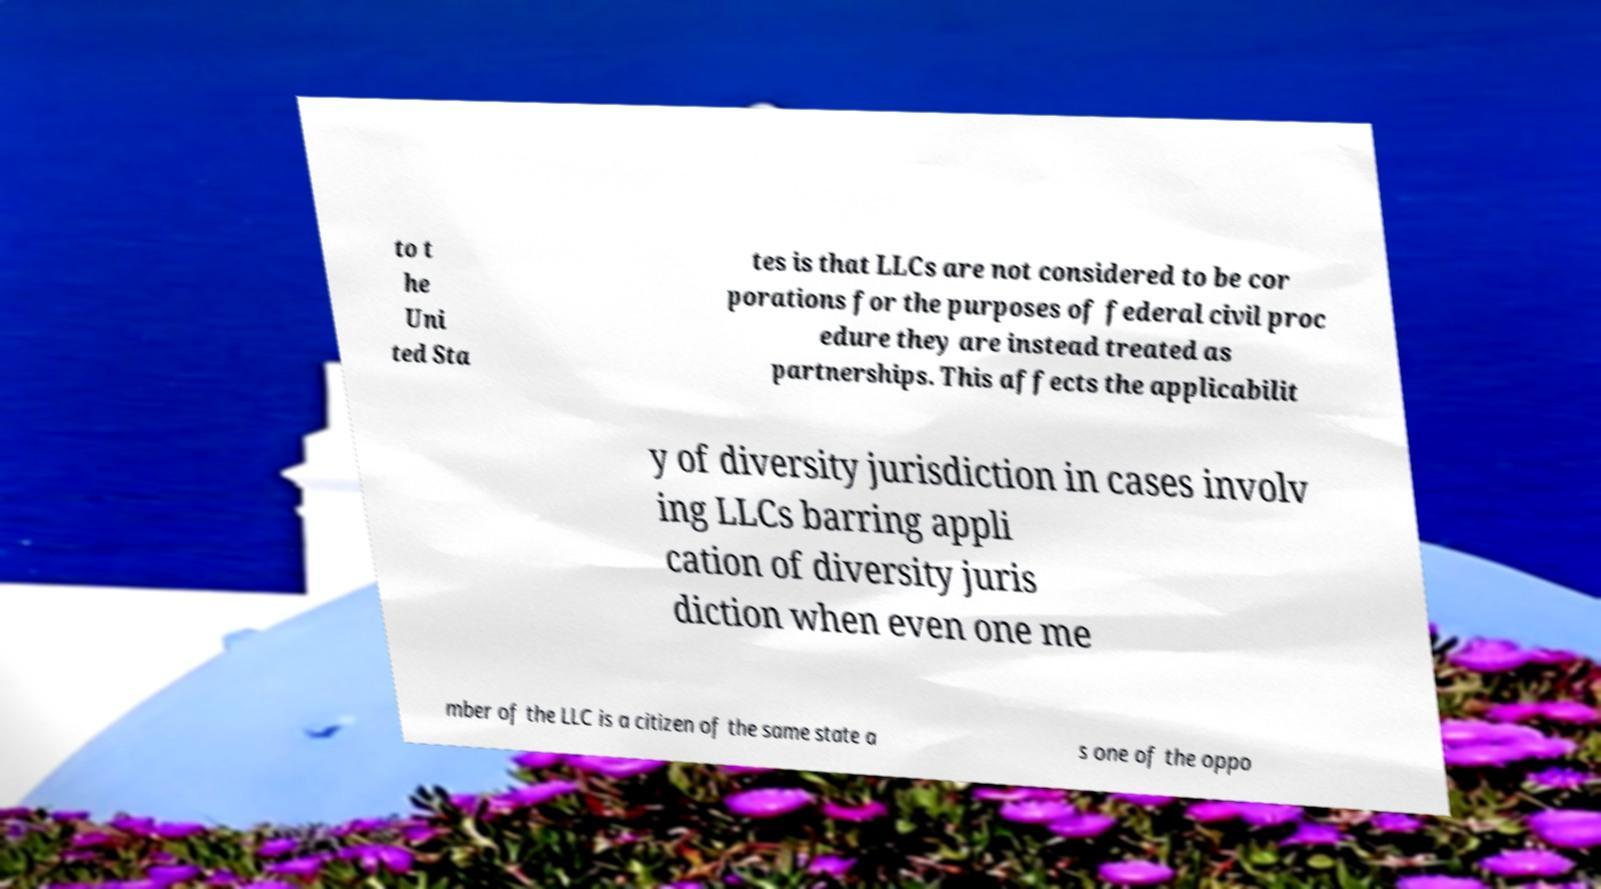Can you accurately transcribe the text from the provided image for me? to t he Uni ted Sta tes is that LLCs are not considered to be cor porations for the purposes of federal civil proc edure they are instead treated as partnerships. This affects the applicabilit y of diversity jurisdiction in cases involv ing LLCs barring appli cation of diversity juris diction when even one me mber of the LLC is a citizen of the same state a s one of the oppo 